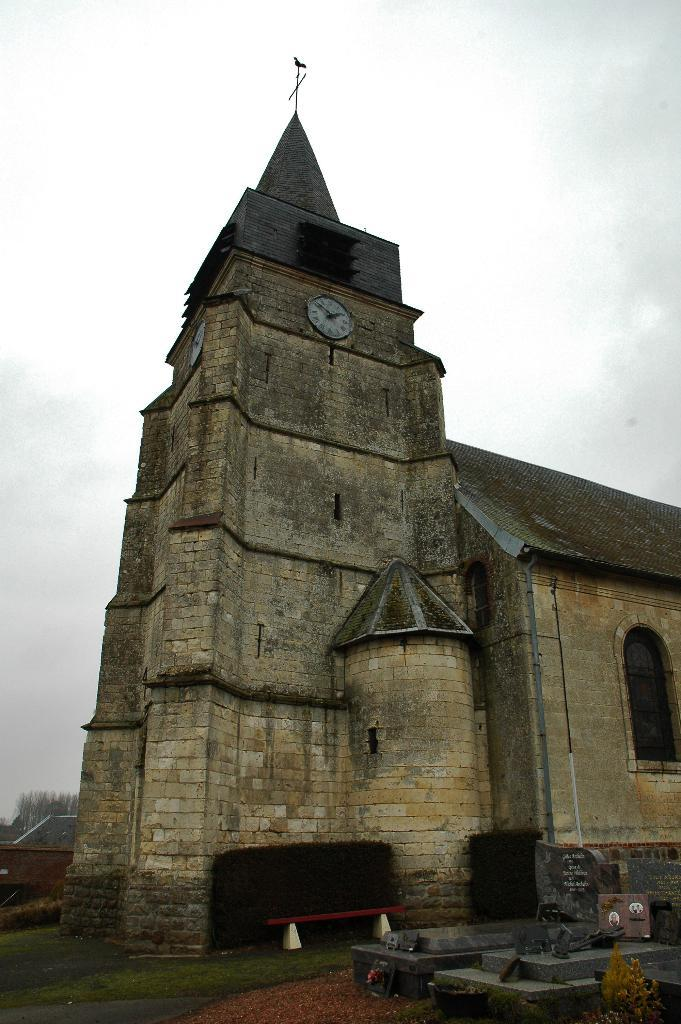What is the main structure in the middle of the image? There is a clock tower in the middle of the image. What can be seen in the background of the image? The sky is visible in the background of the image. What type of glove is hanging from the clock tower in the image? There is no glove present on the clock tower in the image. 